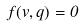Convert formula to latex. <formula><loc_0><loc_0><loc_500><loc_500>f ( v , q ) = 0</formula> 